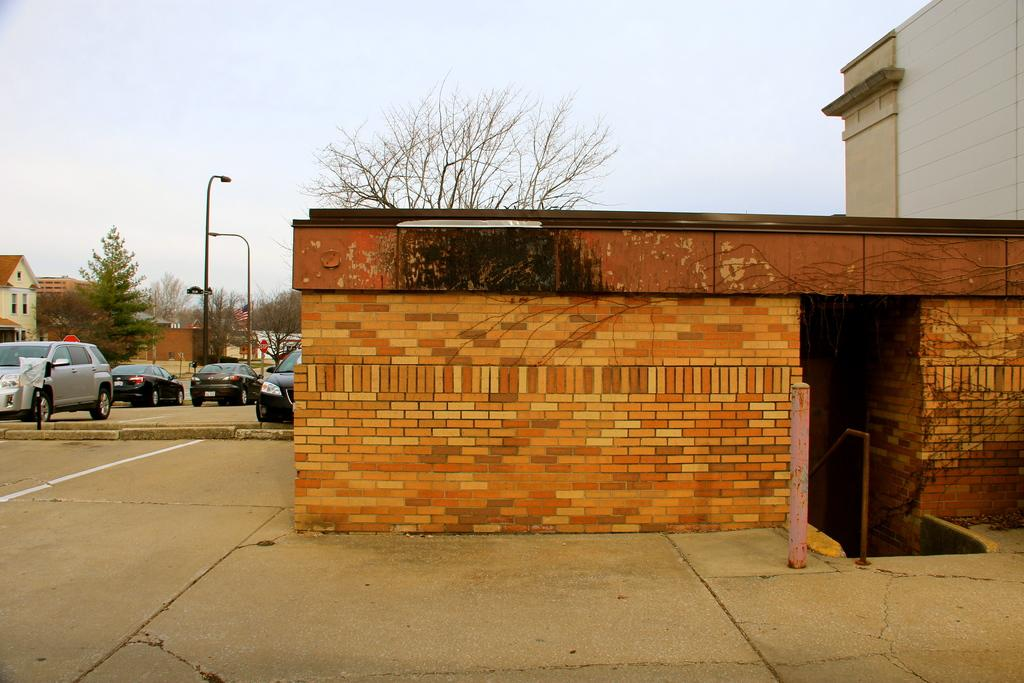What type of structure can be seen in the image? There is a brick wall in the image. What are some vehicles present in the image? Cars are parked in the image. What type of building is visible in the image? There is a building in the image. What type of street furniture can be seen in the image? Light poles are visible in the image. What type of residential structures are present in the image? Houses are present in the image. What is visible in the background of the image? The sky is visible in the background of the image. What type of acoustics can be heard in the image? There is no sound or acoustics present in the image, as it is a still photograph. What theory is being discussed in the image? There is no discussion or theory present in the image, as it is a still photograph. 